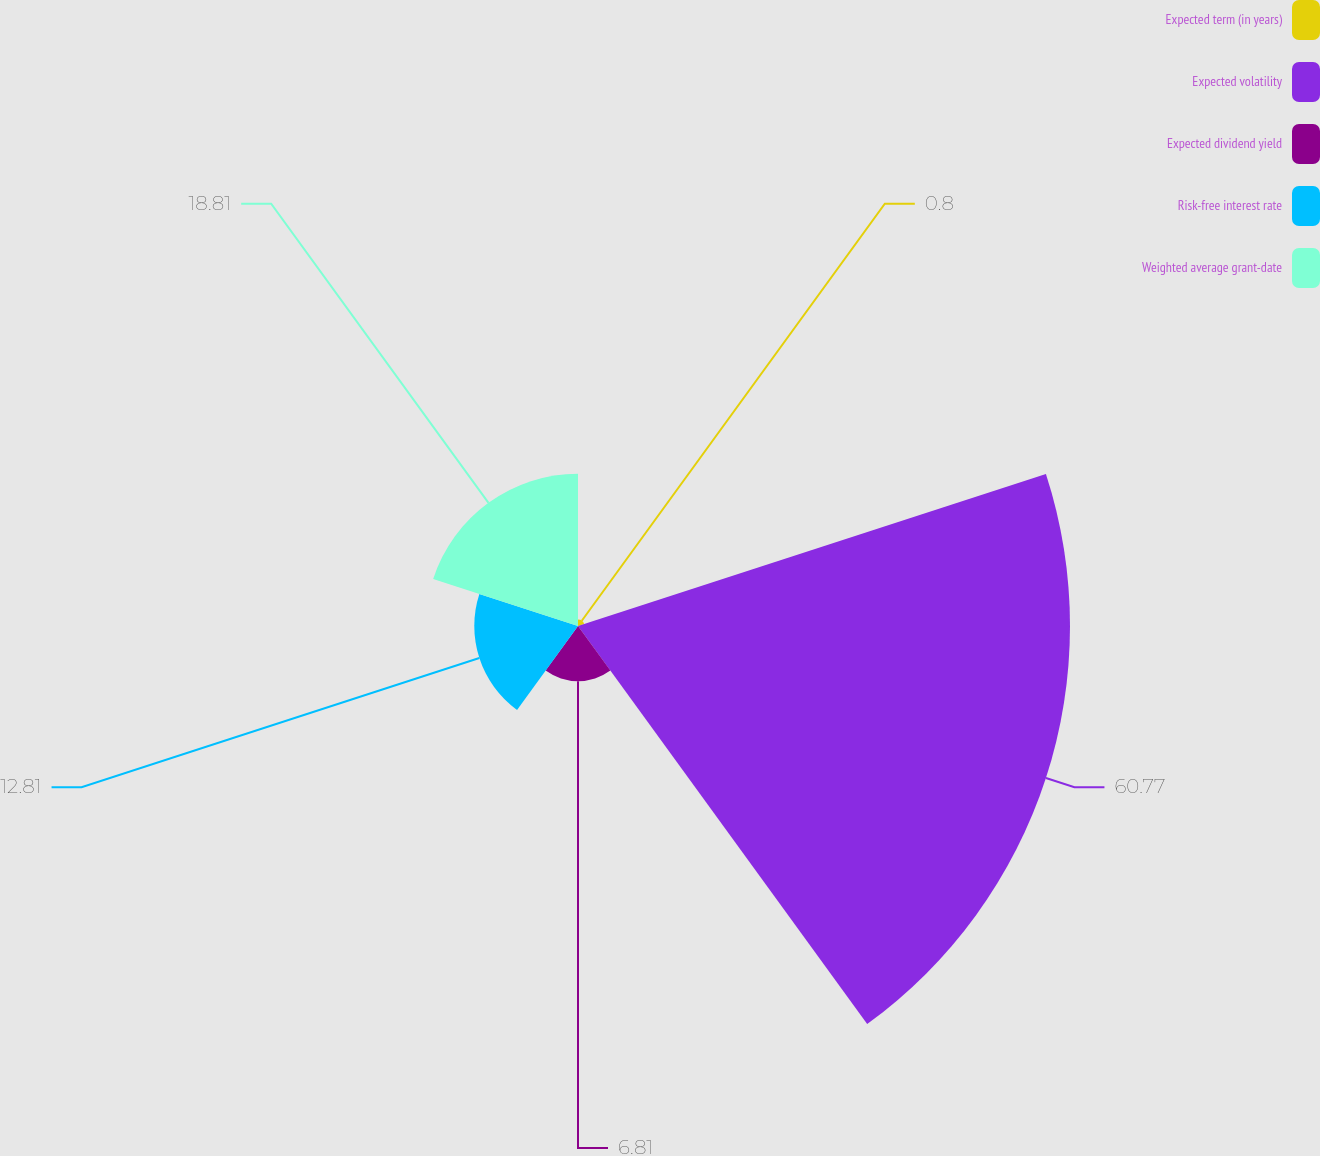Convert chart to OTSL. <chart><loc_0><loc_0><loc_500><loc_500><pie_chart><fcel>Expected term (in years)<fcel>Expected volatility<fcel>Expected dividend yield<fcel>Risk-free interest rate<fcel>Weighted average grant-date<nl><fcel>0.8%<fcel>60.77%<fcel>6.81%<fcel>12.81%<fcel>18.81%<nl></chart> 